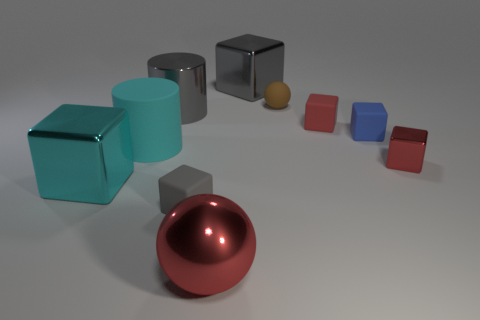Subtract all gray rubber cubes. How many cubes are left? 5 Subtract all blue blocks. How many blocks are left? 5 Subtract all purple blocks. Subtract all green balls. How many blocks are left? 6 Subtract all spheres. How many objects are left? 8 Add 5 brown balls. How many brown balls exist? 6 Subtract 0 brown cylinders. How many objects are left? 10 Subtract all big matte cylinders. Subtract all large gray metal things. How many objects are left? 7 Add 3 small matte blocks. How many small matte blocks are left? 6 